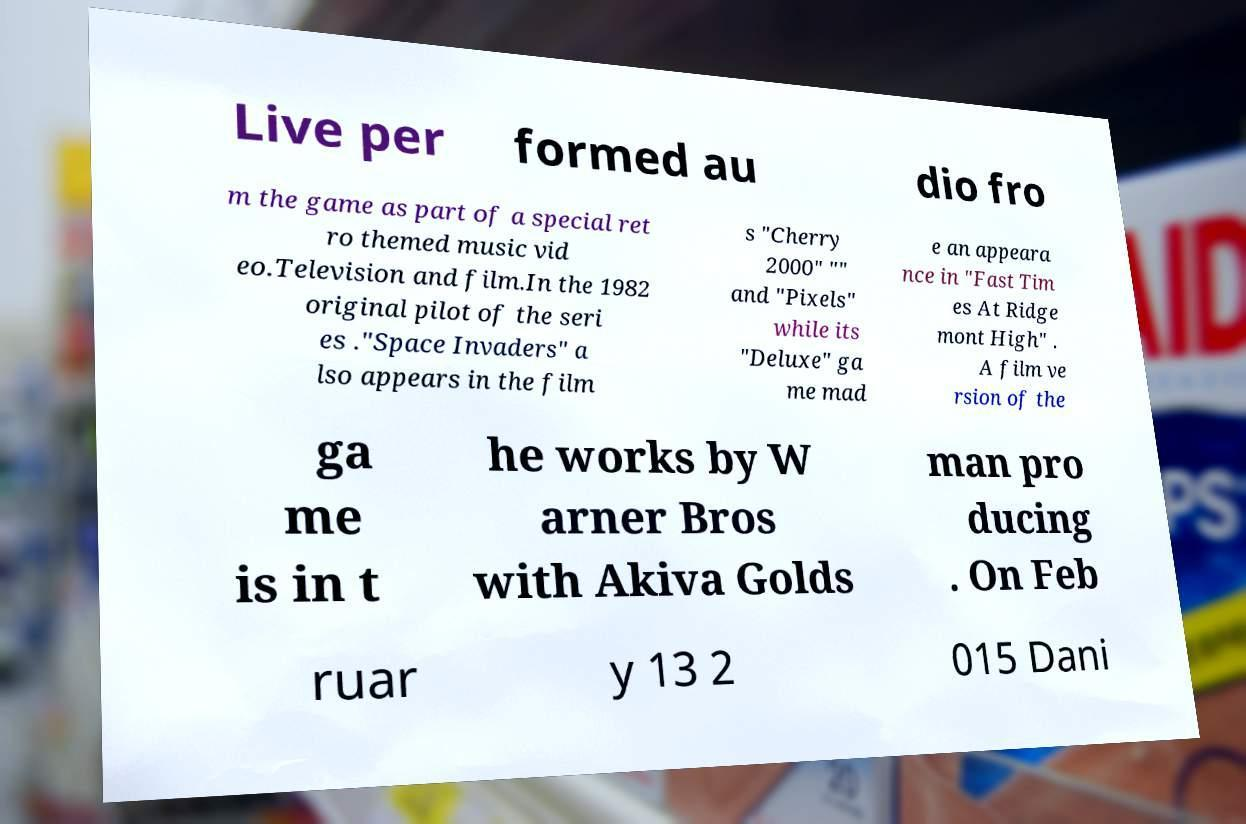For documentation purposes, I need the text within this image transcribed. Could you provide that? Live per formed au dio fro m the game as part of a special ret ro themed music vid eo.Television and film.In the 1982 original pilot of the seri es ."Space Invaders" a lso appears in the film s "Cherry 2000" "" and "Pixels" while its "Deluxe" ga me mad e an appeara nce in "Fast Tim es At Ridge mont High" . A film ve rsion of the ga me is in t he works by W arner Bros with Akiva Golds man pro ducing . On Feb ruar y 13 2 015 Dani 